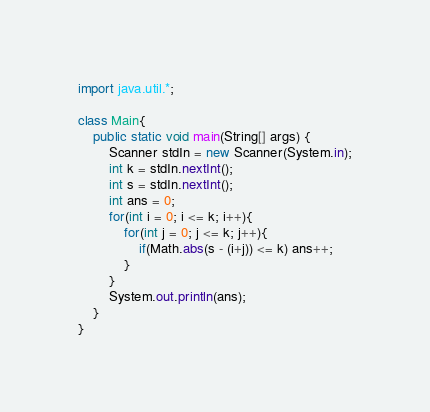Convert code to text. <code><loc_0><loc_0><loc_500><loc_500><_Java_>import java.util.*;

class Main{
    public static void main(String[] args) {
        Scanner stdIn = new Scanner(System.in);
        int k = stdIn.nextInt();
        int s = stdIn.nextInt();
        int ans = 0;
        for(int i = 0; i <= k; i++){
            for(int j = 0; j <= k; j++){
                if(Math.abs(s - (i+j)) <= k) ans++;
            }
        }
        System.out.println(ans);
    }
}</code> 